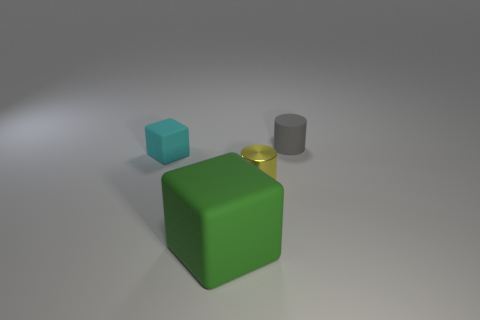What number of cyan objects are made of the same material as the tiny block?
Keep it short and to the point. 0. Do the rubber object to the right of the large green object and the big green thing have the same shape?
Provide a succinct answer. No. There is a object on the left side of the big thing; what is its shape?
Your answer should be compact. Cube. What is the small yellow cylinder made of?
Give a very brief answer. Metal. There is another matte cylinder that is the same size as the yellow cylinder; what is its color?
Make the answer very short. Gray. Is the gray thing the same shape as the metallic object?
Keep it short and to the point. Yes. The small thing that is both on the right side of the big green block and behind the yellow object is made of what material?
Offer a very short reply. Rubber. What is the size of the shiny cylinder?
Your response must be concise. Small. The other thing that is the same shape as the large green object is what color?
Keep it short and to the point. Cyan. Is there any other thing that has the same color as the matte cylinder?
Provide a short and direct response. No. 